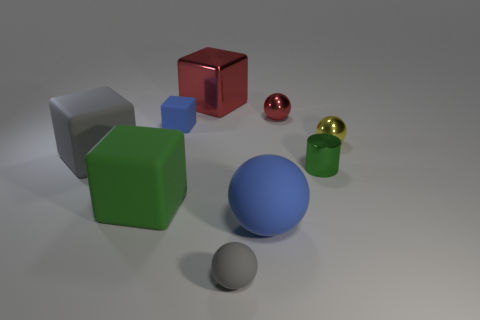Are there any other things that have the same shape as the small green object?
Your response must be concise. No. How many spheres are blue objects or red shiny objects?
Your answer should be compact. 2. There is a large rubber thing behind the green object on the left side of the tiny gray thing; what number of small red metallic objects are on the right side of it?
Your answer should be very brief. 1. There is a thing that is the same color as the tiny rubber ball; what material is it?
Make the answer very short. Rubber. Is the number of metal cylinders greater than the number of balls?
Give a very brief answer. No. Do the blue sphere and the gray ball have the same size?
Your answer should be compact. No. What number of things are big gray cylinders or big red objects?
Your answer should be compact. 1. There is a green thing to the right of the red thing that is right of the shiny thing on the left side of the large matte sphere; what is its shape?
Your response must be concise. Cylinder. Are the block in front of the big gray rubber cube and the big cube that is to the right of the green rubber block made of the same material?
Give a very brief answer. No. There is a tiny yellow thing that is the same shape as the large blue rubber object; what material is it?
Your answer should be very brief. Metal. 